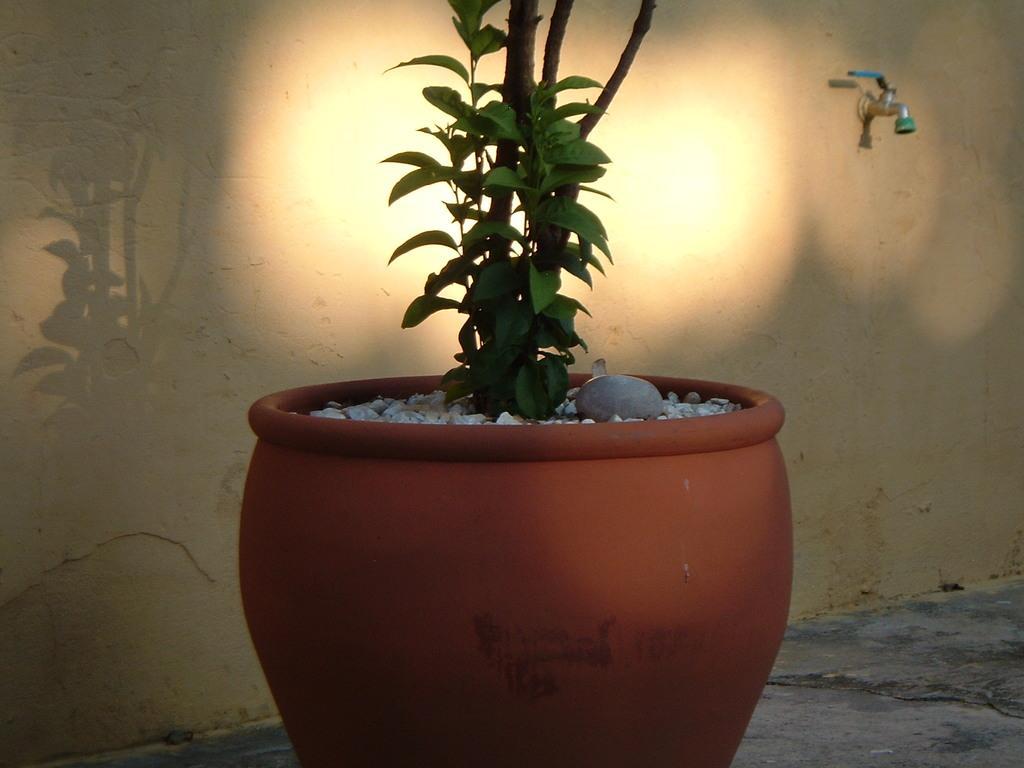Can you describe this image briefly? In this picture I can see a tap to the wall and a plant in the pot and few stones and the pot is brown in color. 